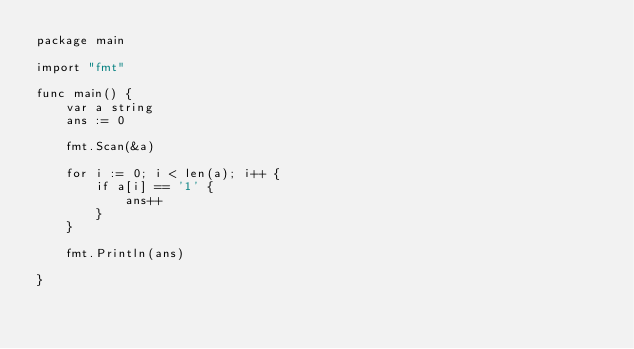Convert code to text. <code><loc_0><loc_0><loc_500><loc_500><_Go_>package main

import "fmt"

func main() {
    var a string
    ans := 0
    
    fmt.Scan(&a)
    
    for i := 0; i < len(a); i++ {
        if a[i] == '1' {
            ans++
        }    
    }
    
    fmt.Println(ans)

}</code> 